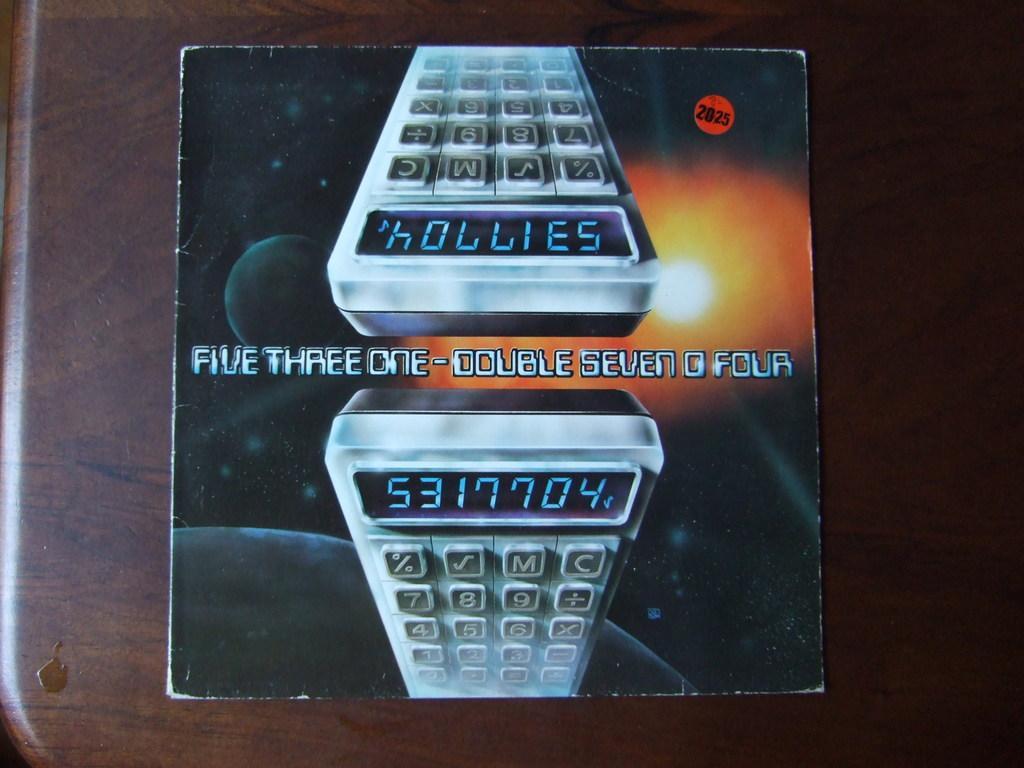In one or two sentences, can you explain what this image depicts? In this picture there is a box on the table. On the box there is a picture of device and there is a text and there is a picture of solar system on the box. 